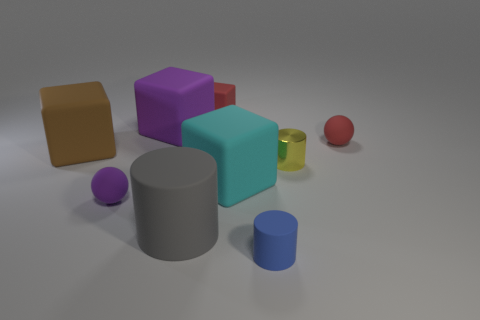Is there anything else that has the same material as the yellow thing?
Offer a very short reply. No. What number of rubber objects are either small blue cylinders or small yellow things?
Ensure brevity in your answer.  1. Is the purple ball made of the same material as the big brown thing?
Offer a terse response. Yes. What is the purple object that is behind the small ball left of the yellow object made of?
Make the answer very short. Rubber. What number of large things are either blue things or cylinders?
Offer a very short reply. 1. What is the size of the metallic object?
Provide a short and direct response. Small. Are there more yellow metallic cylinders that are to the left of the gray matte cylinder than purple rubber cubes?
Provide a succinct answer. No. Are there an equal number of yellow shiny cylinders to the right of the small blue matte cylinder and purple cubes that are right of the large cyan thing?
Give a very brief answer. No. There is a matte thing that is both on the right side of the large cyan matte object and behind the blue object; what is its color?
Provide a short and direct response. Red. Are there any other things that are the same size as the brown rubber thing?
Ensure brevity in your answer.  Yes. 